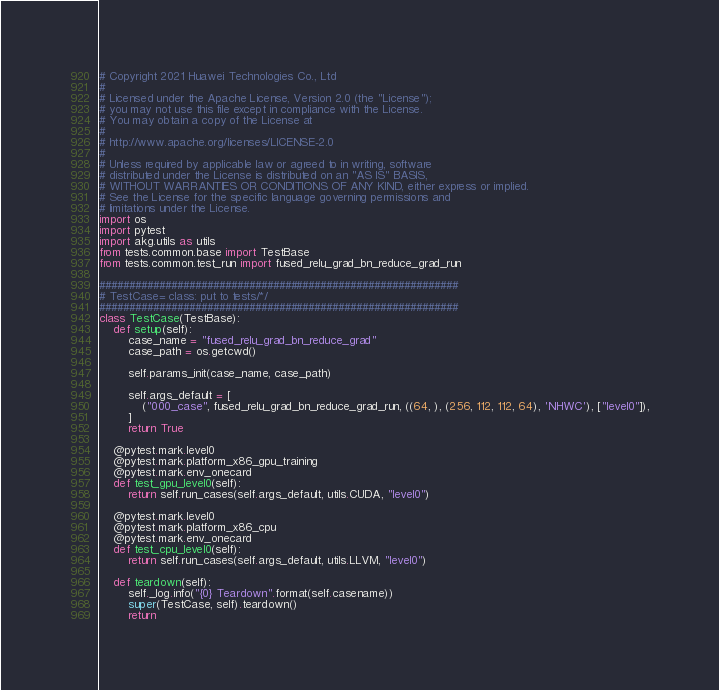<code> <loc_0><loc_0><loc_500><loc_500><_Python_># Copyright 2021 Huawei Technologies Co., Ltd
#
# Licensed under the Apache License, Version 2.0 (the "License");
# you may not use this file except in compliance with the License.
# You may obtain a copy of the License at
#
# http://www.apache.org/licenses/LICENSE-2.0
#
# Unless required by applicable law or agreed to in writing, software
# distributed under the License is distributed on an "AS IS" BASIS,
# WITHOUT WARRANTIES OR CONDITIONS OF ANY KIND, either express or implied.
# See the License for the specific language governing permissions and
# limitations under the License.
import os
import pytest
import akg.utils as utils
from tests.common.base import TestBase
from tests.common.test_run import fused_relu_grad_bn_reduce_grad_run

############################################################
# TestCase= class: put to tests/*/
############################################################
class TestCase(TestBase):
    def setup(self):
        case_name = "fused_relu_grad_bn_reduce_grad"
        case_path = os.getcwd()

        self.params_init(case_name, case_path)

        self.args_default = [
            ("000_case", fused_relu_grad_bn_reduce_grad_run, ((64, ), (256, 112, 112, 64), 'NHWC'), ["level0"]),
        ]
        return True

    @pytest.mark.level0
    @pytest.mark.platform_x86_gpu_training
    @pytest.mark.env_onecard
    def test_gpu_level0(self):
        return self.run_cases(self.args_default, utils.CUDA, "level0")
    
    @pytest.mark.level0
    @pytest.mark.platform_x86_cpu
    @pytest.mark.env_onecard
    def test_cpu_level0(self):
        return self.run_cases(self.args_default, utils.LLVM, "level0")

    def teardown(self):
        self._log.info("{0} Teardown".format(self.casename))
        super(TestCase, self).teardown()
        return</code> 